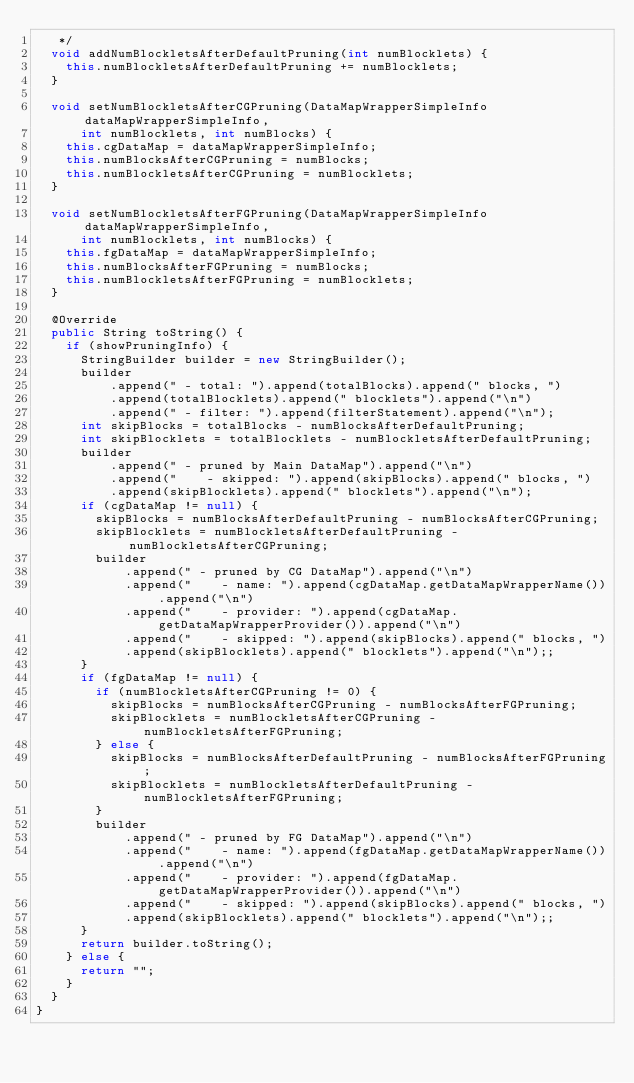Convert code to text. <code><loc_0><loc_0><loc_500><loc_500><_Java_>   */
  void addNumBlockletsAfterDefaultPruning(int numBlocklets) {
    this.numBlockletsAfterDefaultPruning += numBlocklets;
  }

  void setNumBlockletsAfterCGPruning(DataMapWrapperSimpleInfo dataMapWrapperSimpleInfo,
      int numBlocklets, int numBlocks) {
    this.cgDataMap = dataMapWrapperSimpleInfo;
    this.numBlocksAfterCGPruning = numBlocks;
    this.numBlockletsAfterCGPruning = numBlocklets;
  }

  void setNumBlockletsAfterFGPruning(DataMapWrapperSimpleInfo dataMapWrapperSimpleInfo,
      int numBlocklets, int numBlocks) {
    this.fgDataMap = dataMapWrapperSimpleInfo;
    this.numBlocksAfterFGPruning = numBlocks;
    this.numBlockletsAfterFGPruning = numBlocklets;
  }

  @Override
  public String toString() {
    if (showPruningInfo) {
      StringBuilder builder = new StringBuilder();
      builder
          .append(" - total: ").append(totalBlocks).append(" blocks, ")
          .append(totalBlocklets).append(" blocklets").append("\n")
          .append(" - filter: ").append(filterStatement).append("\n");
      int skipBlocks = totalBlocks - numBlocksAfterDefaultPruning;
      int skipBlocklets = totalBlocklets - numBlockletsAfterDefaultPruning;
      builder
          .append(" - pruned by Main DataMap").append("\n")
          .append("    - skipped: ").append(skipBlocks).append(" blocks, ")
          .append(skipBlocklets).append(" blocklets").append("\n");
      if (cgDataMap != null) {
        skipBlocks = numBlocksAfterDefaultPruning - numBlocksAfterCGPruning;
        skipBlocklets = numBlockletsAfterDefaultPruning - numBlockletsAfterCGPruning;
        builder
            .append(" - pruned by CG DataMap").append("\n")
            .append("    - name: ").append(cgDataMap.getDataMapWrapperName()).append("\n")
            .append("    - provider: ").append(cgDataMap.getDataMapWrapperProvider()).append("\n")
            .append("    - skipped: ").append(skipBlocks).append(" blocks, ")
            .append(skipBlocklets).append(" blocklets").append("\n");;
      }
      if (fgDataMap != null) {
        if (numBlockletsAfterCGPruning != 0) {
          skipBlocks = numBlocksAfterCGPruning - numBlocksAfterFGPruning;
          skipBlocklets = numBlockletsAfterCGPruning - numBlockletsAfterFGPruning;
        } else {
          skipBlocks = numBlocksAfterDefaultPruning - numBlocksAfterFGPruning;
          skipBlocklets = numBlockletsAfterDefaultPruning - numBlockletsAfterFGPruning;
        }
        builder
            .append(" - pruned by FG DataMap").append("\n")
            .append("    - name: ").append(fgDataMap.getDataMapWrapperName()).append("\n")
            .append("    - provider: ").append(fgDataMap.getDataMapWrapperProvider()).append("\n")
            .append("    - skipped: ").append(skipBlocks).append(" blocks, ")
            .append(skipBlocklets).append(" blocklets").append("\n");;
      }
      return builder.toString();
    } else {
      return "";
    }
  }
}
</code> 